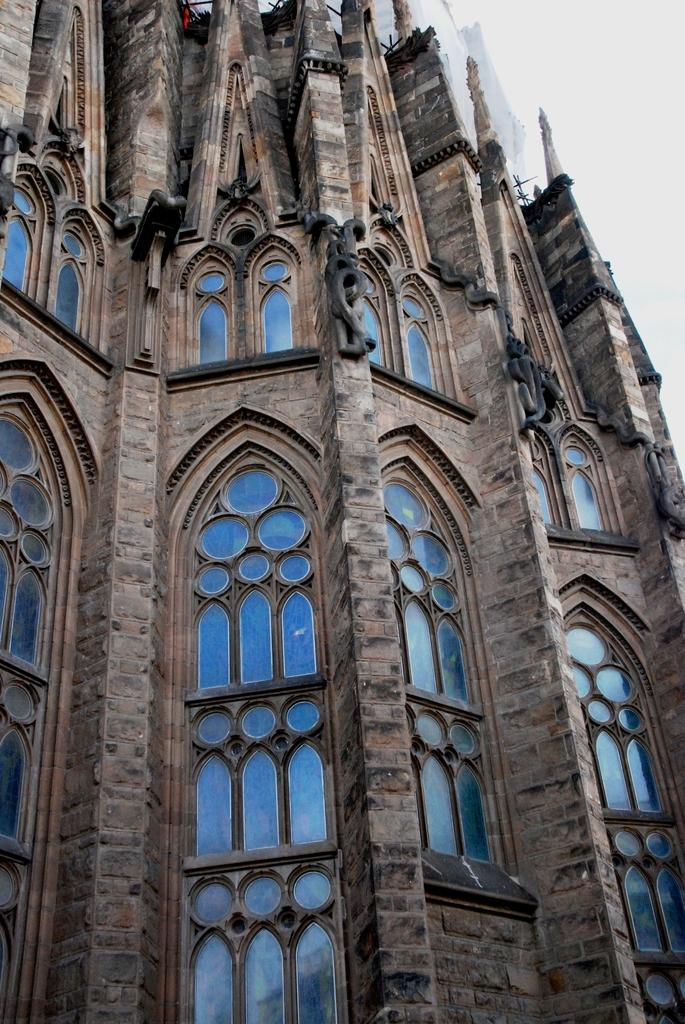What is the main subject of the image? There is a building in the center of the image. What can be seen in the background of the image? There is sky visible in the background of the image. What type of print can be seen on the building in the image? There is no print visible on the building in the image. How does the rake help in maintaining the building in the image? There is no rake present in the image, so it cannot help in maintaining the building. 